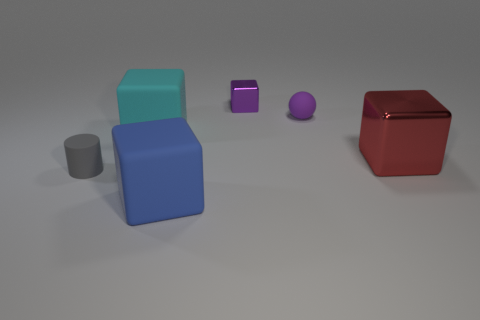Add 3 cyan matte blocks. How many objects exist? 9 Subtract all cyan blocks. How many blocks are left? 3 Subtract all large blue blocks. How many blocks are left? 3 Subtract all blocks. How many objects are left? 2 Subtract 1 cylinders. How many cylinders are left? 0 Subtract all blue blocks. Subtract all gray cylinders. How many blocks are left? 3 Subtract all gray blocks. How many yellow balls are left? 0 Subtract all big brown matte cylinders. Subtract all big metal objects. How many objects are left? 5 Add 3 gray matte cylinders. How many gray matte cylinders are left? 4 Add 6 tiny brown shiny spheres. How many tiny brown shiny spheres exist? 6 